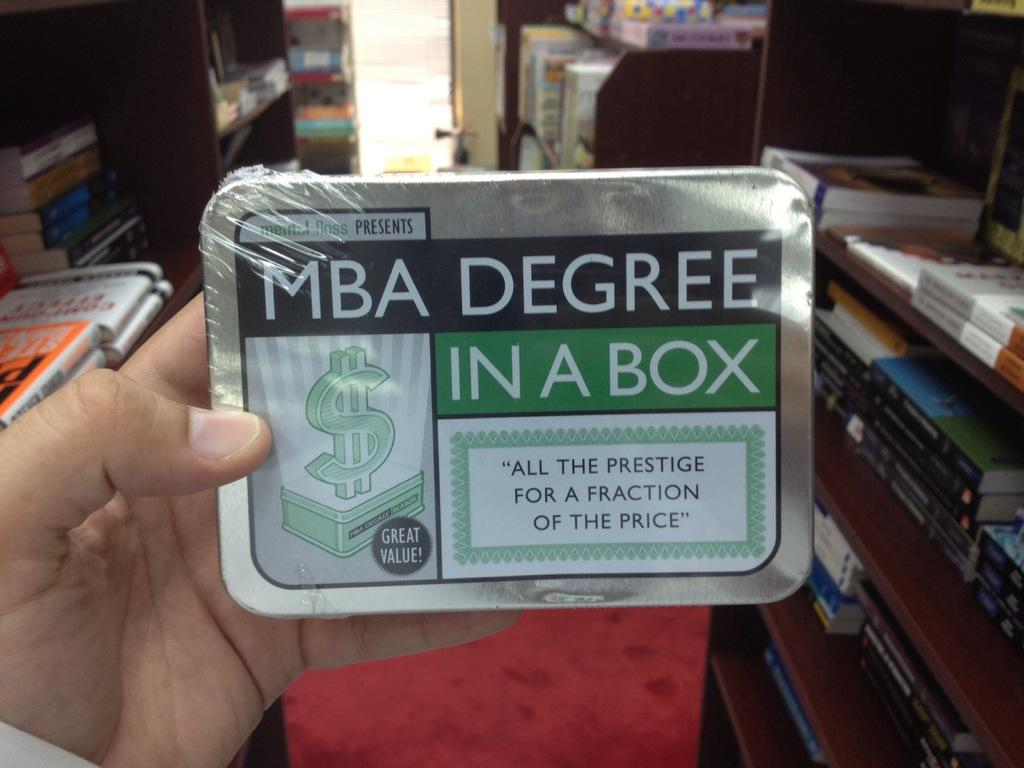<image>
Share a concise interpretation of the image provided. a box that has a label on it that says 'mba degree in a box' 